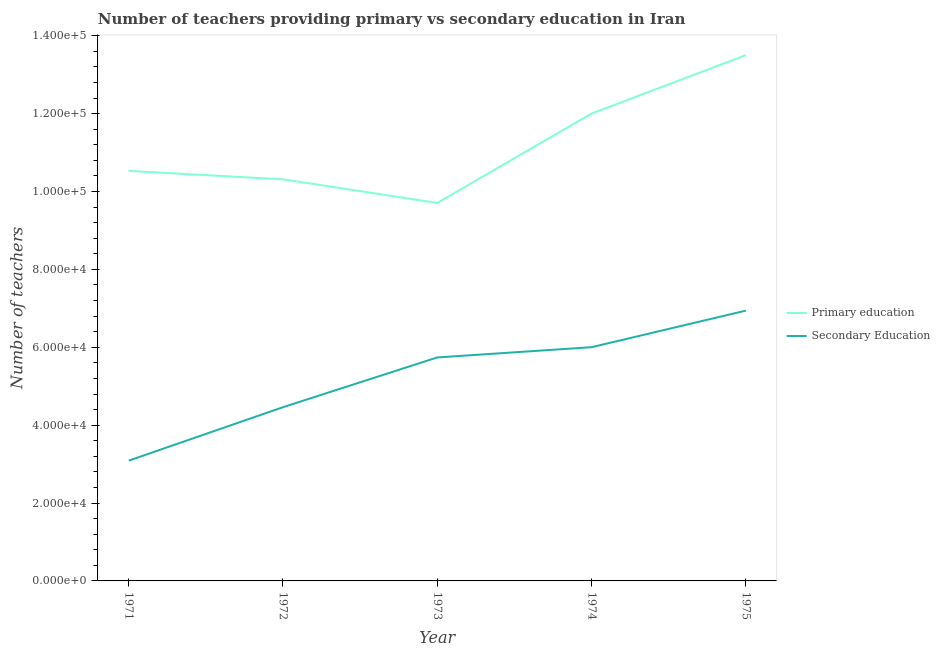How many different coloured lines are there?
Your answer should be very brief. 2. What is the number of secondary teachers in 1971?
Ensure brevity in your answer.  3.09e+04. Across all years, what is the maximum number of primary teachers?
Provide a short and direct response. 1.35e+05. Across all years, what is the minimum number of primary teachers?
Make the answer very short. 9.71e+04. In which year was the number of secondary teachers maximum?
Offer a very short reply. 1975. In which year was the number of secondary teachers minimum?
Make the answer very short. 1971. What is the total number of primary teachers in the graph?
Your response must be concise. 5.61e+05. What is the difference between the number of primary teachers in 1971 and that in 1974?
Provide a succinct answer. -1.47e+04. What is the difference between the number of secondary teachers in 1975 and the number of primary teachers in 1973?
Your answer should be very brief. -2.77e+04. What is the average number of secondary teachers per year?
Make the answer very short. 5.25e+04. In the year 1973, what is the difference between the number of primary teachers and number of secondary teachers?
Offer a very short reply. 3.97e+04. In how many years, is the number of primary teachers greater than 32000?
Provide a short and direct response. 5. What is the ratio of the number of primary teachers in 1973 to that in 1975?
Your response must be concise. 0.72. What is the difference between the highest and the second highest number of secondary teachers?
Your response must be concise. 9392. What is the difference between the highest and the lowest number of secondary teachers?
Your answer should be very brief. 3.85e+04. In how many years, is the number of secondary teachers greater than the average number of secondary teachers taken over all years?
Keep it short and to the point. 3. Is the sum of the number of secondary teachers in 1971 and 1972 greater than the maximum number of primary teachers across all years?
Provide a succinct answer. No. Does the number of primary teachers monotonically increase over the years?
Provide a succinct answer. No. Is the number of primary teachers strictly greater than the number of secondary teachers over the years?
Your answer should be very brief. Yes. Is the number of primary teachers strictly less than the number of secondary teachers over the years?
Make the answer very short. No. How many years are there in the graph?
Make the answer very short. 5. Are the values on the major ticks of Y-axis written in scientific E-notation?
Make the answer very short. Yes. Does the graph contain any zero values?
Your answer should be compact. No. Where does the legend appear in the graph?
Make the answer very short. Center right. How are the legend labels stacked?
Offer a terse response. Vertical. What is the title of the graph?
Offer a very short reply. Number of teachers providing primary vs secondary education in Iran. Does "Fraud firms" appear as one of the legend labels in the graph?
Ensure brevity in your answer.  No. What is the label or title of the Y-axis?
Your answer should be very brief. Number of teachers. What is the Number of teachers of Primary education in 1971?
Your answer should be compact. 1.05e+05. What is the Number of teachers in Secondary Education in 1971?
Offer a very short reply. 3.09e+04. What is the Number of teachers in Primary education in 1972?
Keep it short and to the point. 1.03e+05. What is the Number of teachers of Secondary Education in 1972?
Your response must be concise. 4.46e+04. What is the Number of teachers in Primary education in 1973?
Keep it short and to the point. 9.71e+04. What is the Number of teachers of Secondary Education in 1973?
Your response must be concise. 5.74e+04. What is the Number of teachers in Primary education in 1974?
Give a very brief answer. 1.20e+05. What is the Number of teachers in Secondary Education in 1974?
Your answer should be compact. 6.00e+04. What is the Number of teachers of Primary education in 1975?
Offer a very short reply. 1.35e+05. What is the Number of teachers of Secondary Education in 1975?
Give a very brief answer. 6.94e+04. Across all years, what is the maximum Number of teachers of Primary education?
Your answer should be compact. 1.35e+05. Across all years, what is the maximum Number of teachers of Secondary Education?
Your answer should be compact. 6.94e+04. Across all years, what is the minimum Number of teachers in Primary education?
Provide a short and direct response. 9.71e+04. Across all years, what is the minimum Number of teachers of Secondary Education?
Make the answer very short. 3.09e+04. What is the total Number of teachers of Primary education in the graph?
Make the answer very short. 5.61e+05. What is the total Number of teachers in Secondary Education in the graph?
Provide a short and direct response. 2.62e+05. What is the difference between the Number of teachers of Primary education in 1971 and that in 1972?
Keep it short and to the point. 2165. What is the difference between the Number of teachers of Secondary Education in 1971 and that in 1972?
Your answer should be compact. -1.37e+04. What is the difference between the Number of teachers in Primary education in 1971 and that in 1973?
Provide a succinct answer. 8224. What is the difference between the Number of teachers of Secondary Education in 1971 and that in 1973?
Ensure brevity in your answer.  -2.65e+04. What is the difference between the Number of teachers of Primary education in 1971 and that in 1974?
Ensure brevity in your answer.  -1.47e+04. What is the difference between the Number of teachers of Secondary Education in 1971 and that in 1974?
Provide a short and direct response. -2.91e+04. What is the difference between the Number of teachers in Primary education in 1971 and that in 1975?
Your answer should be very brief. -2.97e+04. What is the difference between the Number of teachers in Secondary Education in 1971 and that in 1975?
Provide a short and direct response. -3.85e+04. What is the difference between the Number of teachers in Primary education in 1972 and that in 1973?
Provide a succinct answer. 6059. What is the difference between the Number of teachers of Secondary Education in 1972 and that in 1973?
Provide a short and direct response. -1.28e+04. What is the difference between the Number of teachers of Primary education in 1972 and that in 1974?
Offer a terse response. -1.69e+04. What is the difference between the Number of teachers in Secondary Education in 1972 and that in 1974?
Provide a succinct answer. -1.54e+04. What is the difference between the Number of teachers in Primary education in 1972 and that in 1975?
Offer a very short reply. -3.19e+04. What is the difference between the Number of teachers in Secondary Education in 1972 and that in 1975?
Your answer should be compact. -2.48e+04. What is the difference between the Number of teachers of Primary education in 1973 and that in 1974?
Make the answer very short. -2.29e+04. What is the difference between the Number of teachers in Secondary Education in 1973 and that in 1974?
Ensure brevity in your answer.  -2631. What is the difference between the Number of teachers of Primary education in 1973 and that in 1975?
Make the answer very short. -3.80e+04. What is the difference between the Number of teachers in Secondary Education in 1973 and that in 1975?
Provide a short and direct response. -1.20e+04. What is the difference between the Number of teachers in Primary education in 1974 and that in 1975?
Offer a terse response. -1.50e+04. What is the difference between the Number of teachers in Secondary Education in 1974 and that in 1975?
Provide a short and direct response. -9392. What is the difference between the Number of teachers in Primary education in 1971 and the Number of teachers in Secondary Education in 1972?
Give a very brief answer. 6.07e+04. What is the difference between the Number of teachers in Primary education in 1971 and the Number of teachers in Secondary Education in 1973?
Your response must be concise. 4.79e+04. What is the difference between the Number of teachers in Primary education in 1971 and the Number of teachers in Secondary Education in 1974?
Your answer should be compact. 4.53e+04. What is the difference between the Number of teachers of Primary education in 1971 and the Number of teachers of Secondary Education in 1975?
Keep it short and to the point. 3.59e+04. What is the difference between the Number of teachers in Primary education in 1972 and the Number of teachers in Secondary Education in 1973?
Your answer should be very brief. 4.57e+04. What is the difference between the Number of teachers in Primary education in 1972 and the Number of teachers in Secondary Education in 1974?
Provide a short and direct response. 4.31e+04. What is the difference between the Number of teachers of Primary education in 1972 and the Number of teachers of Secondary Education in 1975?
Offer a terse response. 3.37e+04. What is the difference between the Number of teachers of Primary education in 1973 and the Number of teachers of Secondary Education in 1974?
Ensure brevity in your answer.  3.70e+04. What is the difference between the Number of teachers in Primary education in 1973 and the Number of teachers in Secondary Education in 1975?
Provide a short and direct response. 2.77e+04. What is the difference between the Number of teachers of Primary education in 1974 and the Number of teachers of Secondary Education in 1975?
Offer a very short reply. 5.06e+04. What is the average Number of teachers of Primary education per year?
Offer a terse response. 1.12e+05. What is the average Number of teachers in Secondary Education per year?
Offer a very short reply. 5.25e+04. In the year 1971, what is the difference between the Number of teachers in Primary education and Number of teachers in Secondary Education?
Provide a short and direct response. 7.44e+04. In the year 1972, what is the difference between the Number of teachers in Primary education and Number of teachers in Secondary Education?
Provide a short and direct response. 5.85e+04. In the year 1973, what is the difference between the Number of teachers of Primary education and Number of teachers of Secondary Education?
Your response must be concise. 3.97e+04. In the year 1974, what is the difference between the Number of teachers of Primary education and Number of teachers of Secondary Education?
Your answer should be very brief. 6.00e+04. In the year 1975, what is the difference between the Number of teachers of Primary education and Number of teachers of Secondary Education?
Provide a short and direct response. 6.56e+04. What is the ratio of the Number of teachers in Primary education in 1971 to that in 1972?
Make the answer very short. 1.02. What is the ratio of the Number of teachers of Secondary Education in 1971 to that in 1972?
Your answer should be compact. 0.69. What is the ratio of the Number of teachers of Primary education in 1971 to that in 1973?
Your answer should be very brief. 1.08. What is the ratio of the Number of teachers of Secondary Education in 1971 to that in 1973?
Offer a very short reply. 0.54. What is the ratio of the Number of teachers of Primary education in 1971 to that in 1974?
Give a very brief answer. 0.88. What is the ratio of the Number of teachers in Secondary Education in 1971 to that in 1974?
Provide a succinct answer. 0.51. What is the ratio of the Number of teachers of Primary education in 1971 to that in 1975?
Give a very brief answer. 0.78. What is the ratio of the Number of teachers in Secondary Education in 1971 to that in 1975?
Your answer should be very brief. 0.45. What is the ratio of the Number of teachers in Primary education in 1972 to that in 1973?
Make the answer very short. 1.06. What is the ratio of the Number of teachers in Secondary Education in 1972 to that in 1973?
Your answer should be compact. 0.78. What is the ratio of the Number of teachers in Primary education in 1972 to that in 1974?
Ensure brevity in your answer.  0.86. What is the ratio of the Number of teachers of Secondary Education in 1972 to that in 1974?
Your answer should be very brief. 0.74. What is the ratio of the Number of teachers of Primary education in 1972 to that in 1975?
Your response must be concise. 0.76. What is the ratio of the Number of teachers in Secondary Education in 1972 to that in 1975?
Ensure brevity in your answer.  0.64. What is the ratio of the Number of teachers of Primary education in 1973 to that in 1974?
Make the answer very short. 0.81. What is the ratio of the Number of teachers of Secondary Education in 1973 to that in 1974?
Provide a short and direct response. 0.96. What is the ratio of the Number of teachers of Primary education in 1973 to that in 1975?
Offer a terse response. 0.72. What is the ratio of the Number of teachers in Secondary Education in 1973 to that in 1975?
Your answer should be compact. 0.83. What is the ratio of the Number of teachers of Secondary Education in 1974 to that in 1975?
Provide a short and direct response. 0.86. What is the difference between the highest and the second highest Number of teachers of Primary education?
Provide a succinct answer. 1.50e+04. What is the difference between the highest and the second highest Number of teachers of Secondary Education?
Offer a very short reply. 9392. What is the difference between the highest and the lowest Number of teachers in Primary education?
Your answer should be very brief. 3.80e+04. What is the difference between the highest and the lowest Number of teachers of Secondary Education?
Make the answer very short. 3.85e+04. 